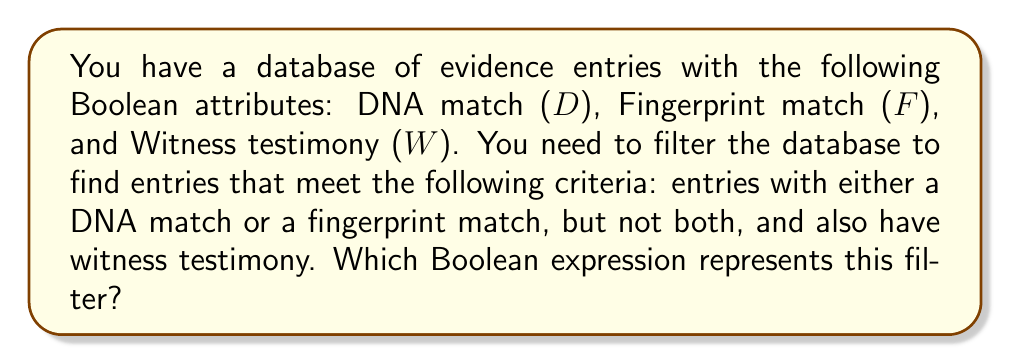Could you help me with this problem? Let's approach this step-by-step:

1) We need entries with either DNA match or fingerprint match, but not both. This is an exclusive OR (XOR) operation, which can be represented as:

   $$(D \oplus F)$$

2) We also need entries that have witness testimony. This is an AND operation with the previous result:

   $$(D \oplus F) \land W$$

3) To expand the XOR operation, we can use its definition in terms of AND, OR, and NOT:

   $$((D \lor F) \land \lnot(D \land F)) \land W$$

4) Using the distributive property of AND over OR, we can simplify this to:

   $$(D \land \lnot F \land W) \lor (F \land \lnot D \land W)$$

This final expression represents our desired filter: entries with DNA match but no fingerprint match and with witness testimony, OR entries with fingerprint match but no DNA match and with witness testimony.
Answer: $(D \land \lnot F \land W) \lor (F \land \lnot D \land W)$ 